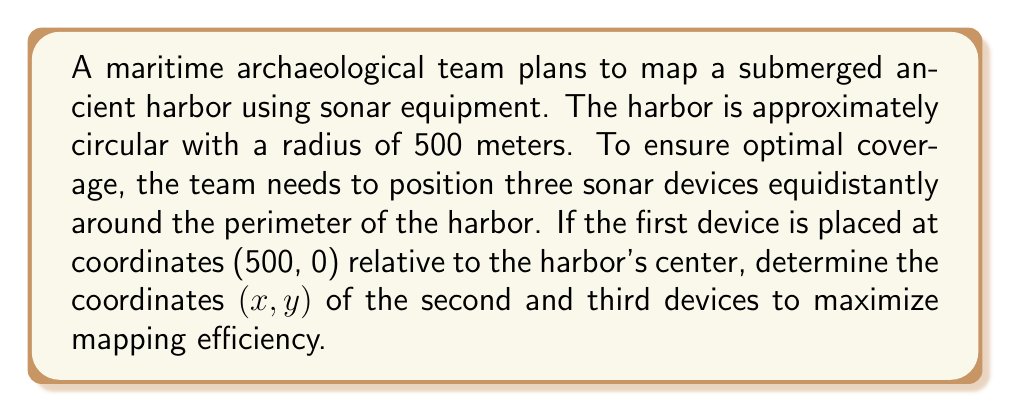Help me with this question. To solve this problem, we'll use concepts from field theory and geometry:

1) The harbor is circular, so we can use polar coordinates to represent points on its perimeter.

2) We need to place three devices equidistantly, which means they should be 120° apart (360° / 3 = 120°).

3) The first device is at (500, 0), which corresponds to an angle of 0° in polar coordinates.

4) For the second device, we need to rotate 120° counterclockwise:
   $x = r \cos(\theta) = 500 \cos(120°) = 500 \cdot (-0.5) = -250$
   $y = r \sin(\theta) = 500 \sin(120°) = 500 \cdot (\frac{\sqrt{3}}{2}) \approx 433.01$

5) For the third device, we rotate another 120° (total 240°):
   $x = r \cos(\theta) = 500 \cos(240°) = 500 \cdot (-0.5) = -250$
   $y = r \sin(\theta) = 500 \sin(240°) = 500 \cdot (-\frac{\sqrt{3}}{2}) \approx -433.01$

[asy]
unitsize(0.1cm);
draw(circle((0,0),50));
dot((50,0),red);
dot((-25,43.3),red);
dot((-25,-43.3),red);
label("1",(50,0),E);
label("2",(-25,43.3),NW);
label("3",(-25,-43.3),SW);
label("500m",(25,0),N);
draw((0,0)--(50,0),dashed);
[/asy]
Answer: Second device: (-250, 433.01), Third device: (-250, -433.01) 